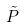<formula> <loc_0><loc_0><loc_500><loc_500>\tilde { P }</formula> 